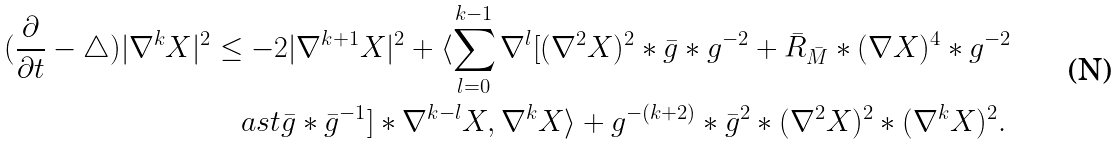Convert formula to latex. <formula><loc_0><loc_0><loc_500><loc_500>( \frac { \partial } { \partial t } - { \triangle } ) | { \nabla ^ { k } } { X } | ^ { 2 } & \leq - 2 | { \nabla ^ { k + 1 } } { X } | ^ { 2 } + \langle \sum _ { l = 0 } ^ { k - 1 } \nabla ^ { l } [ ( \nabla ^ { 2 } { X } ) ^ { 2 } \ast \bar { g } \ast g ^ { - 2 } + \bar { R } _ { \bar { M } } \ast ( \nabla X ) ^ { 4 } \ast g ^ { - 2 } \\ & \quad a s t \bar { g } \ast \bar { g } ^ { - 1 } ] \ast \nabla ^ { k - l } X , \nabla ^ { k } X \rangle + g ^ { - ( k + 2 ) } \ast \bar { g } ^ { 2 } \ast ( \nabla ^ { 2 } X ) ^ { 2 } \ast ( \nabla ^ { k } X ) ^ { 2 } .</formula> 